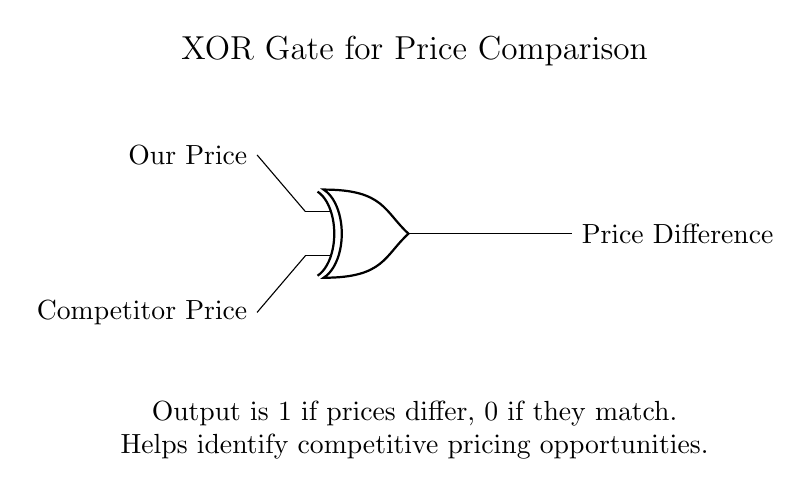What are the inputs to the XOR gate? The inputs are "Our Price" and "Competitor Price", as labeled on the left side of the diagram.
Answer: Our Price, Competitor Price What does the output represent? The output represents the "Price Difference", indicating if there is a difference between the two price inputs.
Answer: Price Difference What will the output be if both prices are the same? If both the "Our Price" and "Competitor Price" are equal, the output of the XOR gate will be 0, indicating no price difference.
Answer: 0 What is the output when the prices differ? When "Our Price" and "Competitor Price" are not equal, the output will be 1, indicating a price difference exists.
Answer: 1 What type of logic gate is shown in this circuit? The circuit uses an XOR gate, which is characterized by its output being true only when the inputs are different.
Answer: XOR gate How does this circuit assist in pricing strategy? This circuit helps identify competitive pricing opportunities by indicating whether prices are aligned or differ, guiding pricing strategies accordingly.
Answer: Competitive pricing opportunities 